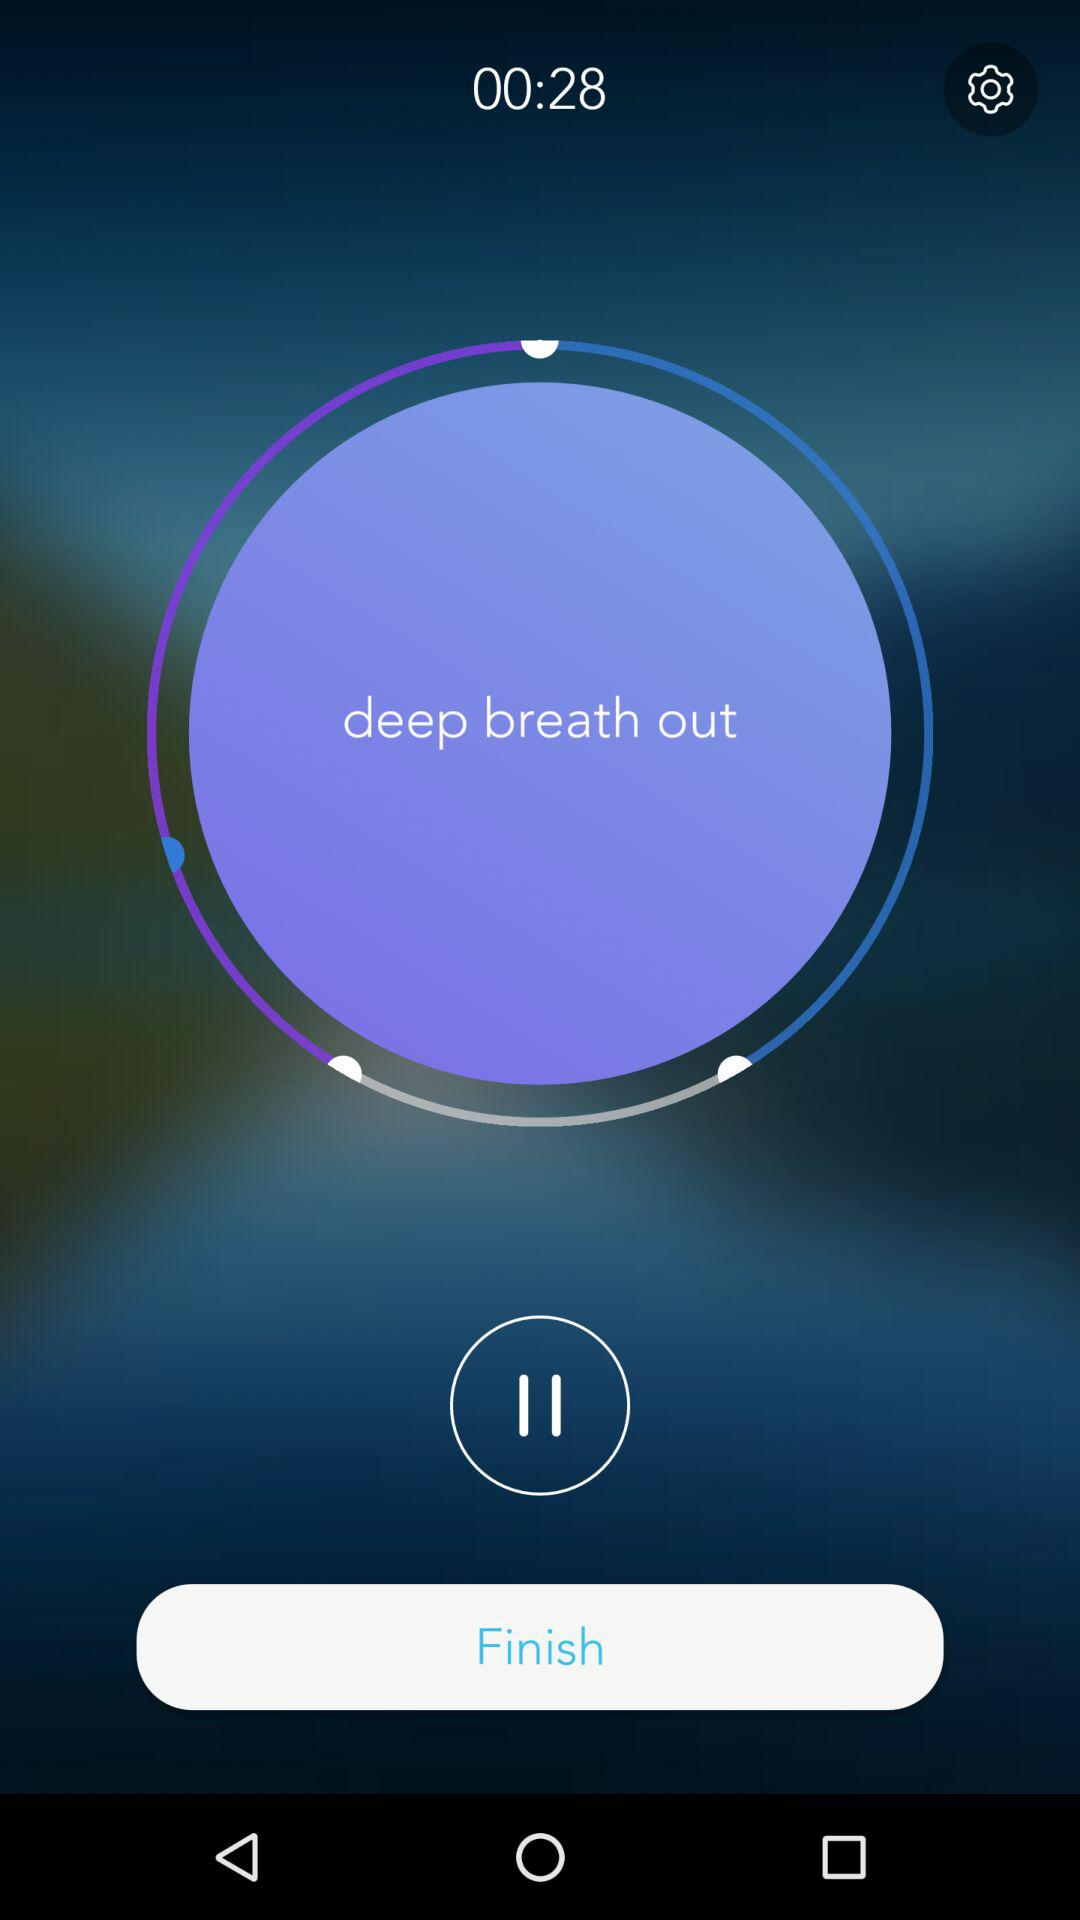How many seconds are there? There are 28 seconds. 